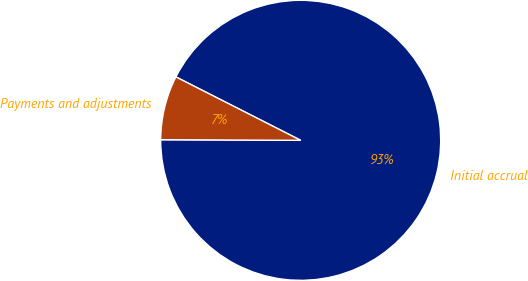<chart> <loc_0><loc_0><loc_500><loc_500><pie_chart><fcel>Initial accrual<fcel>Payments and adjustments<nl><fcel>92.59%<fcel>7.41%<nl></chart> 